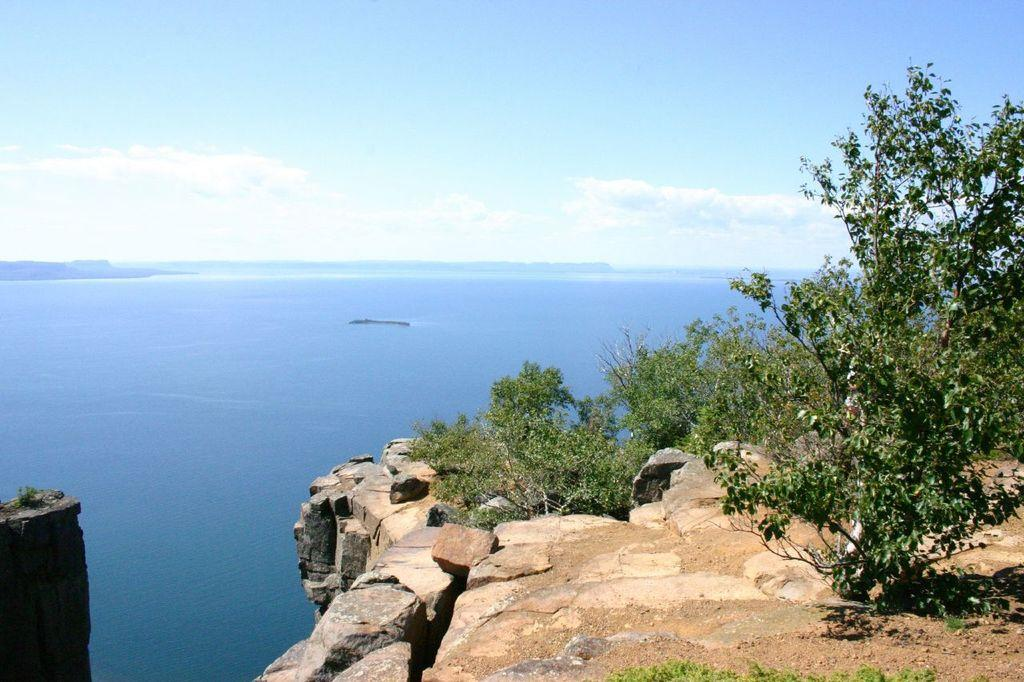What type of natural body of water is visible in the image? The image contains the sea. What geological features can be seen in the image? There are rocks in the image. What type of vegetation is present in the image? Plants, grass, and trees are visible in the image. How would you describe the sky in the image? The sky is cloudy in the image. What type of wing can be seen on the bird in the image? There are no birds or wings present in the image. How many quills are visible on the creature in the image? There are no creatures or quills present in the image. 